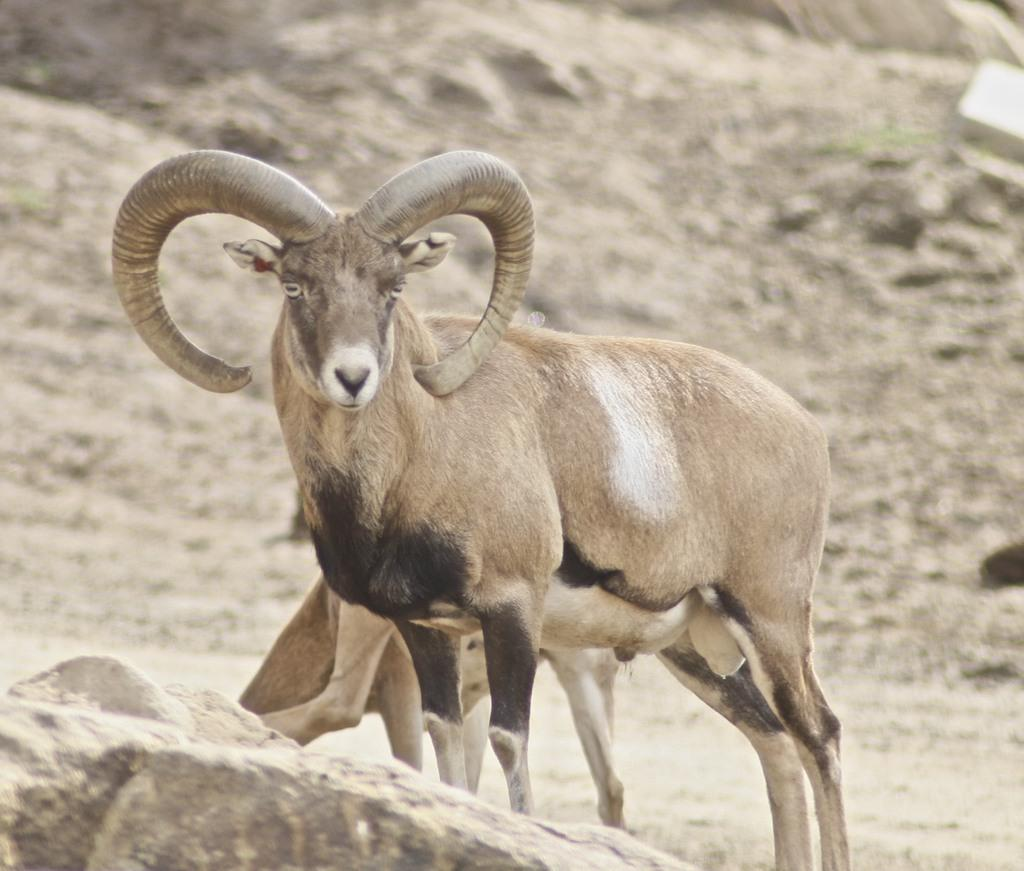What animal is present in the image? There is a goat in the image. Where is the goat located? The goat is standing on the land. How many hooks are attached to the goat in the image? There are no hooks present in the image; the goat is simply standing on the land. 